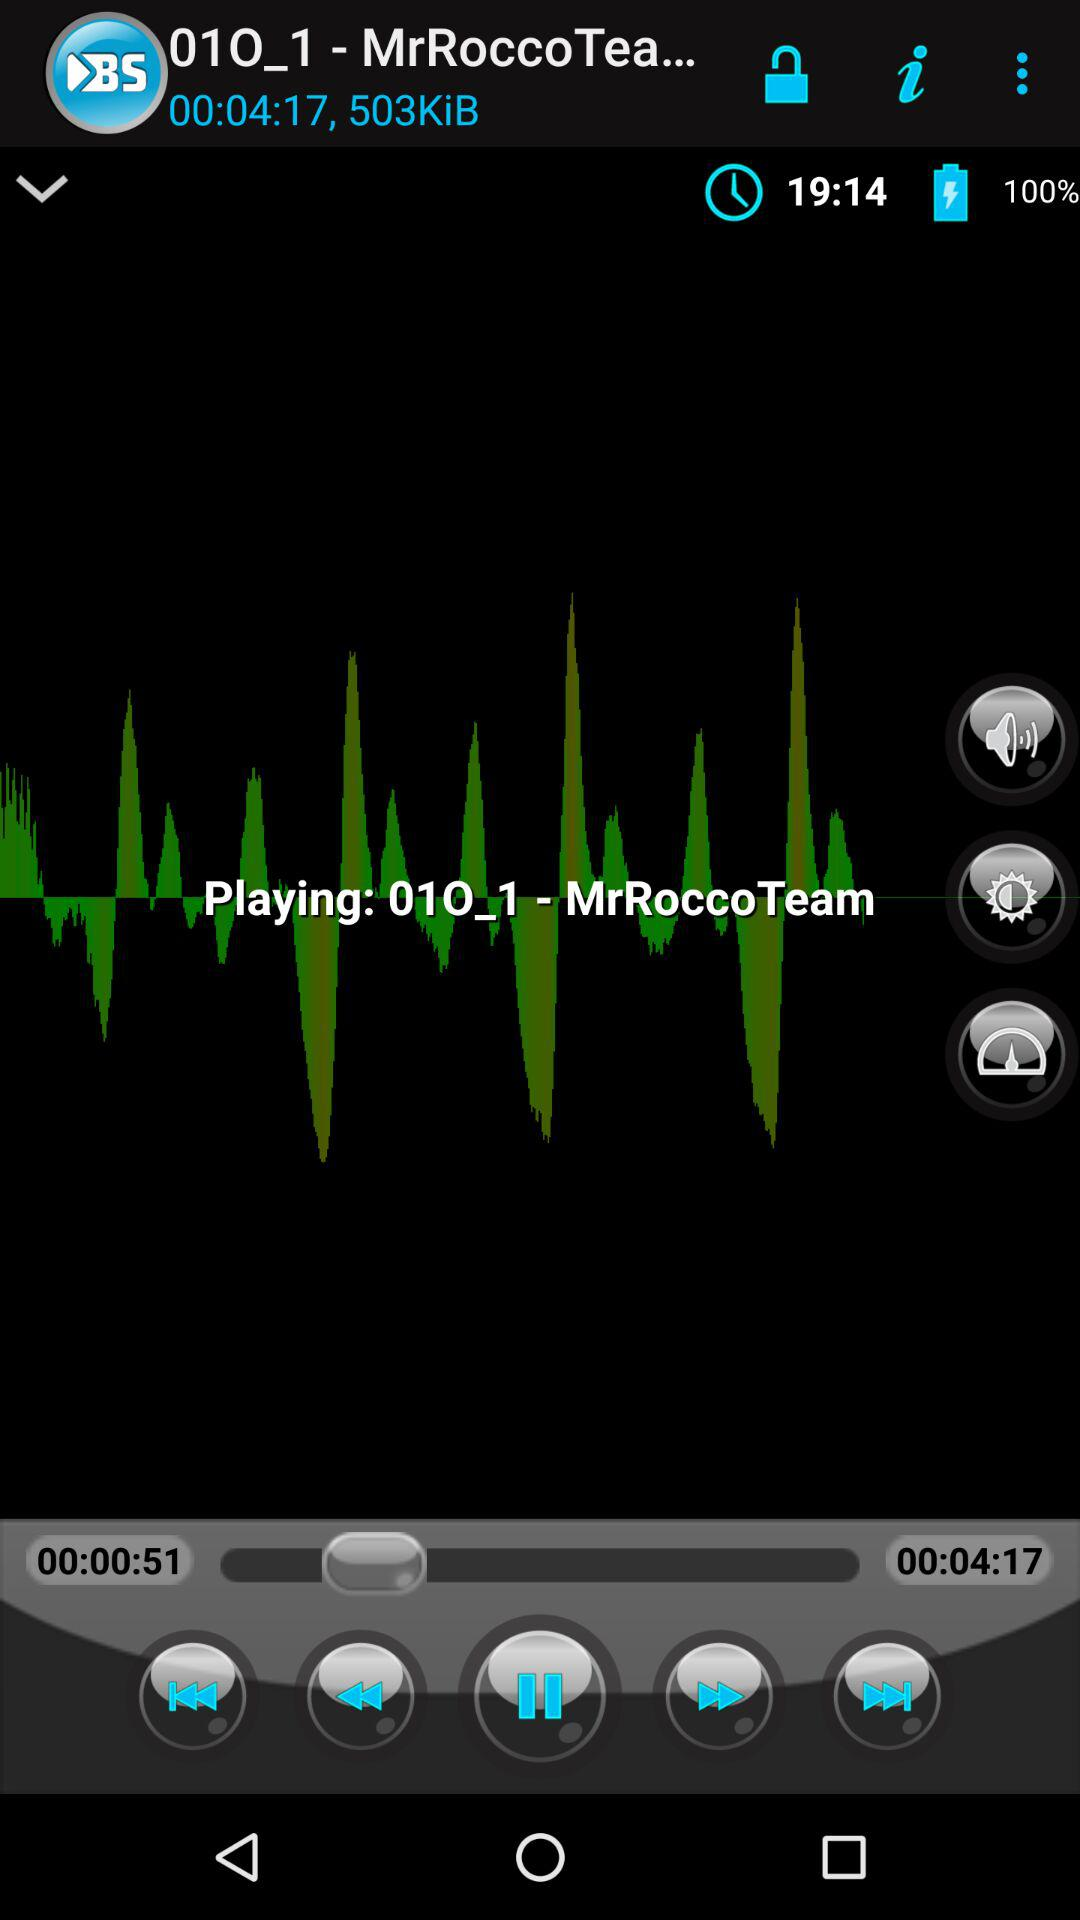What is the size of the song in KiB? The size of the song is 503 KiB. 